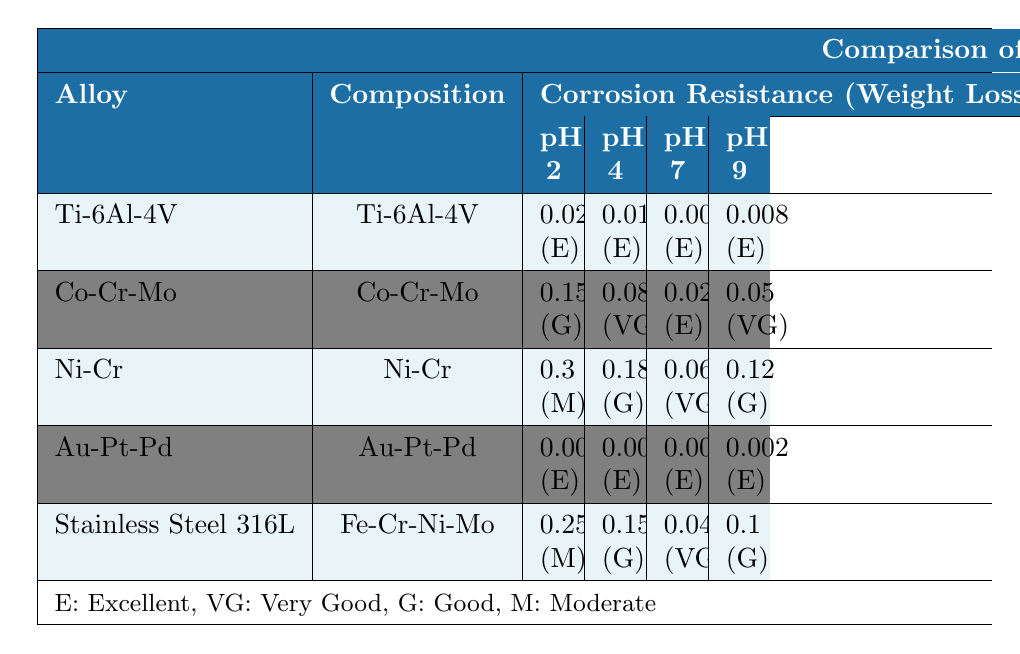What is the corrosion resistance of Titanium-6Aluminum-4Vanadium at pH 7? The table states that the corrosion resistance of Titanium-6Aluminum-4Vanadium at pH 7 is categorized as Excellent.
Answer: Excellent Which dental alloy has the lowest weight loss at pH 4? By comparing the weight loss values at pH 4 for all the dental alloys, the lowest is 0.003 mg/cm2/year from Gold-Platinum-Palladium.
Answer: 0.003 mg/cm2/year Is the biocompatibility of Nickel-Chromium high? The table indicates that Nickel-Chromium has low biocompatibility, therefore the statement is false.
Answer: No What is the average weight loss of the alloys at pH 2? The weight loss values at pH 2 are: Titanium-6Aluminum-4Vanadium (0.02), Cobalt-Chromium-Molybdenum (0.15), Nickel-Chromium (0.3), Gold-Platinum-Palladium (0.005), and Stainless Steel 316L (0.25). Summing these gives 0.02 + 0.15 + 0.3 + 0.005 + 0.25 = 0.725. There are 5 alloys, so the average weight loss is 0.725 / 5 = 0.145 mg/cm2/year.
Answer: 0.145 mg/cm2/year Which alloy is best for dental applications requiring very high biocompatibility? Based on the table, Gold-Platinum-Palladium is rated as Very High for biocompatibility, making it the best choice.
Answer: Gold-Platinum-Palladium What is the weight loss of Cobalt-Chromium-Molybdenum at pH 9? The table shows that the weight loss for Cobalt-Chromium-Molybdenum at pH 9 is 0.05 mg/cm2/year.
Answer: 0.05 mg/cm2/year 